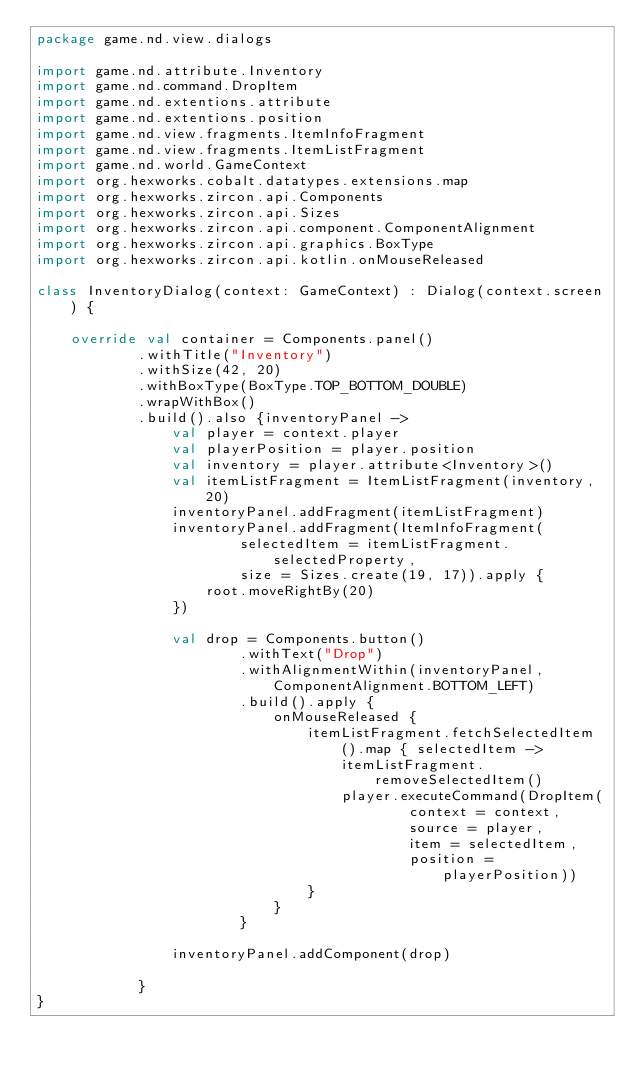<code> <loc_0><loc_0><loc_500><loc_500><_Kotlin_>package game.nd.view.dialogs

import game.nd.attribute.Inventory
import game.nd.command.DropItem
import game.nd.extentions.attribute
import game.nd.extentions.position
import game.nd.view.fragments.ItemInfoFragment
import game.nd.view.fragments.ItemListFragment
import game.nd.world.GameContext
import org.hexworks.cobalt.datatypes.extensions.map
import org.hexworks.zircon.api.Components
import org.hexworks.zircon.api.Sizes
import org.hexworks.zircon.api.component.ComponentAlignment
import org.hexworks.zircon.api.graphics.BoxType
import org.hexworks.zircon.api.kotlin.onMouseReleased

class InventoryDialog(context: GameContext) : Dialog(context.screen) {

    override val container = Components.panel()
            .withTitle("Inventory")
            .withSize(42, 20)
            .withBoxType(BoxType.TOP_BOTTOM_DOUBLE)
            .wrapWithBox()
            .build().also {inventoryPanel ->
                val player = context.player
                val playerPosition = player.position
                val inventory = player.attribute<Inventory>()
                val itemListFragment = ItemListFragment(inventory, 20)
                inventoryPanel.addFragment(itemListFragment)
                inventoryPanel.addFragment(ItemInfoFragment(
                        selectedItem = itemListFragment.selectedProperty,
                        size = Sizes.create(19, 17)).apply {
                    root.moveRightBy(20)
                })

                val drop = Components.button()
                        .withText("Drop")
                        .withAlignmentWithin(inventoryPanel, ComponentAlignment.BOTTOM_LEFT)
                        .build().apply {
                            onMouseReleased {
                                itemListFragment.fetchSelectedItem().map { selectedItem ->
                                    itemListFragment.removeSelectedItem()
                                    player.executeCommand(DropItem(
                                            context = context,
                                            source = player,
                                            item = selectedItem,
                                            position = playerPosition))
                                }
                            }
                        }

                inventoryPanel.addComponent(drop)

            }
}</code> 